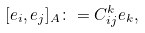Convert formula to latex. <formula><loc_0><loc_0><loc_500><loc_500>[ e _ { i } , e _ { j } ] _ { A } \colon = C _ { i j } ^ { k } e _ { k } ,</formula> 